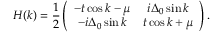<formula> <loc_0><loc_0><loc_500><loc_500>H ( k ) = \frac { 1 } { 2 } \left ( \begin{array} { c c } { - t \cos k - \mu } & { i \Delta _ { 0 } \sin k } \\ { - i \Delta _ { 0 } \sin k } & { t \cos k + \mu } \end{array} \right ) .</formula> 